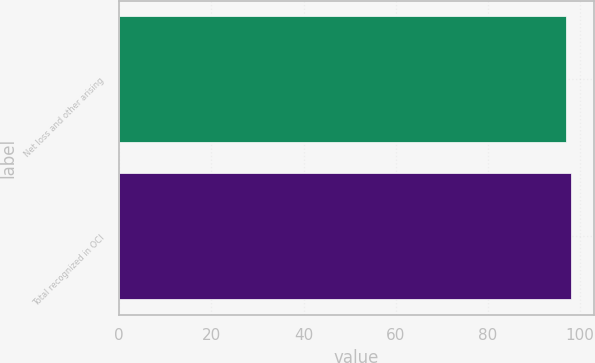Convert chart to OTSL. <chart><loc_0><loc_0><loc_500><loc_500><bar_chart><fcel>Net loss and other arising<fcel>Total recognized in OCI<nl><fcel>97<fcel>98<nl></chart> 